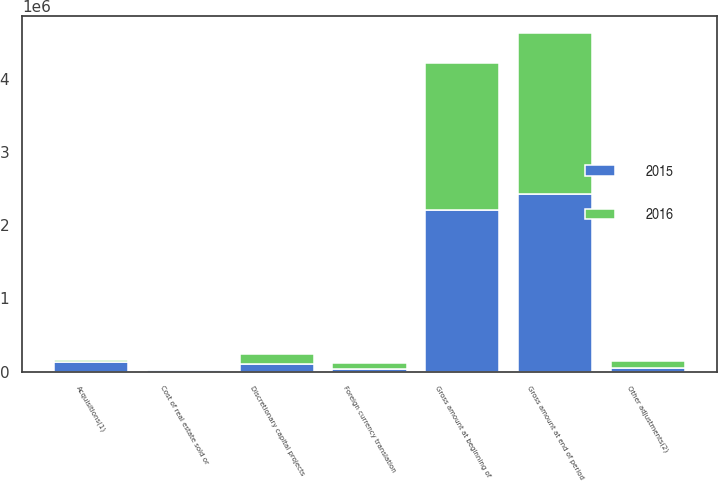Convert chart to OTSL. <chart><loc_0><loc_0><loc_500><loc_500><stacked_bar_chart><ecel><fcel>Gross amount at beginning of<fcel>Acquisitions(1)<fcel>Discretionary capital projects<fcel>Other adjustments(2)<fcel>Foreign currency translation<fcel>Cost of real estate sold or<fcel>Gross amount at end of period<nl><fcel>2016<fcel>2.01958e+06<fcel>33180<fcel>136398<fcel>101386<fcel>85092<fcel>469<fcel>2.20499e+06<nl><fcel>2015<fcel>2.20499e+06<fcel>131665<fcel>108760<fcel>42904<fcel>37653<fcel>23124<fcel>2.42754e+06<nl></chart> 